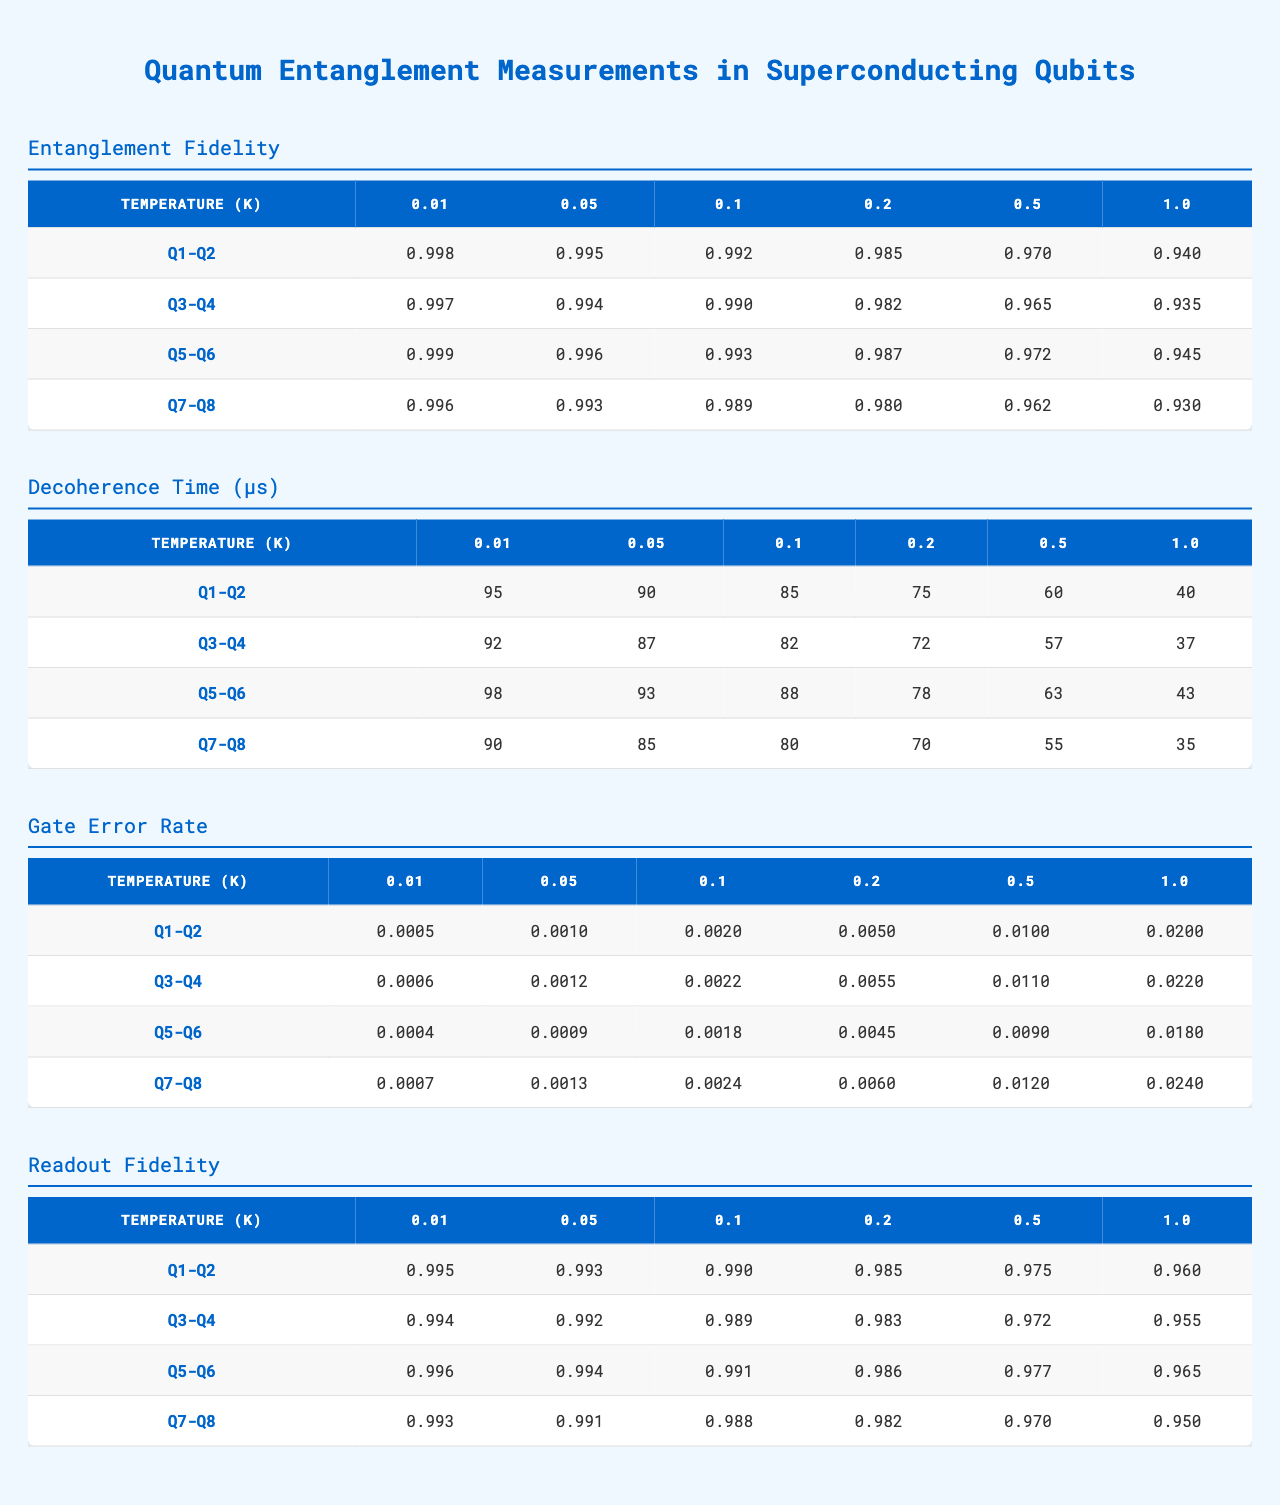What is the entanglement fidelity for qubit pair Q1-Q2 at a temperature of 0.1 K? The table shows the entanglement fidelity for Q1-Q2 at 0.1 K, which is 0.992.
Answer: 0.992 What is the decoherence time for qubit pair Q5-Q6 at 0.5 K? According to the table, the decoherence time for Q5-Q6 at 0.5 K is 63 μs.
Answer: 63 μs Is the gate error rate for qubit pair Q3-Q4 higher at 0.2 K than at 0.5 K? At 0.2 K, the gate error rate for Q3-Q4 is 0.0055, whereas at 0.5 K, it is 0.011. Since 0.0055 < 0.011, the statement is true; it indicates that the gate error rate is higher at 0.5 K.
Answer: Yes What is the readout fidelity at 1.0 K for qubit pair Q7-Q8? The readout fidelity for Q7-Q8 at 1.0 K is listed as 0.950 in the table.
Answer: 0.950 What is the average entanglement fidelity across all qubit pairs at a temperature of 0.01 K? To find the average, first sum the entanglement fidelities at 0.01 K: 0.998 + 0.997 + 0.999 + 0.996 = 3.990. Then divide by the number of qubit pairs (4): 3.990 / 4 = 0.9975.
Answer: 0.9975 At which temperature does qubit pair Q1-Q2 show the lowest decoherence time? The lowest decoherence time for Q1-Q2 occurs at 1.0 K with a value of 40 μs, according to the table.
Answer: 1.0 K Is the readout fidelity for Q5-Q6 consistently higher than that for Q3-Q4 across all temperatures? The table indicates that for each temperature, the readout fidelity values for Q5-Q6 (0.996, 0.994, 0.991, 0.986, 0.977, 0.965) are higher than those for Q3-Q4 (0.994, 0.992, 0.989, 0.983, 0.972, 0.955). Thus, the statement is true.
Answer: Yes What is the difference in the gate error rate between Q7-Q8 at 0.5 K and Q1-Q2 at the same temperature? The gate error rate for Q7-Q8 at 0.5 K is 0.012, while for Q1-Q2 at the same temperature, it is 0.01. The difference is calculated as 0.012 - 0.01 = 0.002.
Answer: 0.002 Which qubit pair has the highest readout fidelity at 0.2 K? According to the table, at 0.2 K, the readout fidelity for Q5-Q6 is 0.986, which is the highest compared to the other pairs.
Answer: Q5-Q6 What temperature corresponds to the highest gate error rate for qubit pair Q3-Q4? For qubit pair Q3-Q4, the highest gate error rate is observed at 1.0 K, where the rate is 0.022.
Answer: 1.0 K 